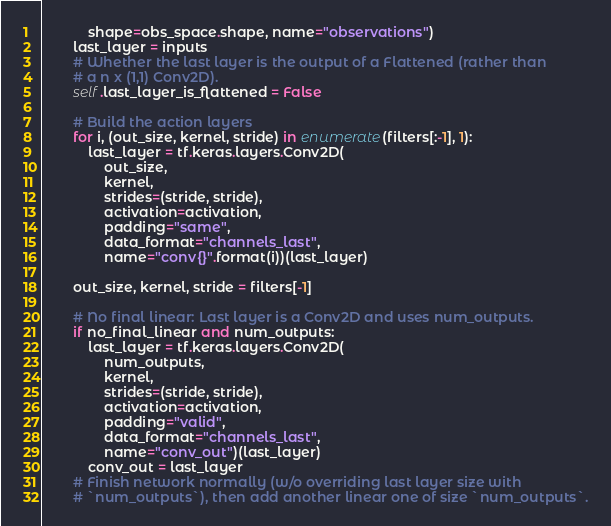<code> <loc_0><loc_0><loc_500><loc_500><_Python_>            shape=obs_space.shape, name="observations")
        last_layer = inputs
        # Whether the last layer is the output of a Flattened (rather than
        # a n x (1,1) Conv2D).
        self.last_layer_is_flattened = False

        # Build the action layers
        for i, (out_size, kernel, stride) in enumerate(filters[:-1], 1):
            last_layer = tf.keras.layers.Conv2D(
                out_size,
                kernel,
                strides=(stride, stride),
                activation=activation,
                padding="same",
                data_format="channels_last",
                name="conv{}".format(i))(last_layer)

        out_size, kernel, stride = filters[-1]

        # No final linear: Last layer is a Conv2D and uses num_outputs.
        if no_final_linear and num_outputs:
            last_layer = tf.keras.layers.Conv2D(
                num_outputs,
                kernel,
                strides=(stride, stride),
                activation=activation,
                padding="valid",
                data_format="channels_last",
                name="conv_out")(last_layer)
            conv_out = last_layer
        # Finish network normally (w/o overriding last layer size with
        # `num_outputs`), then add another linear one of size `num_outputs`.</code> 